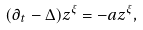<formula> <loc_0><loc_0><loc_500><loc_500>( \partial _ { t } - \Delta ) z ^ { \xi } = - a z ^ { \xi } ,</formula> 